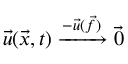Convert formula to latex. <formula><loc_0><loc_0><loc_500><loc_500>\ V e c { u } ( \ V e c { x } , t ) \xrightarrow { - \ V e c { u } ( \ V e c { f } ) } \ V e c { 0 }</formula> 